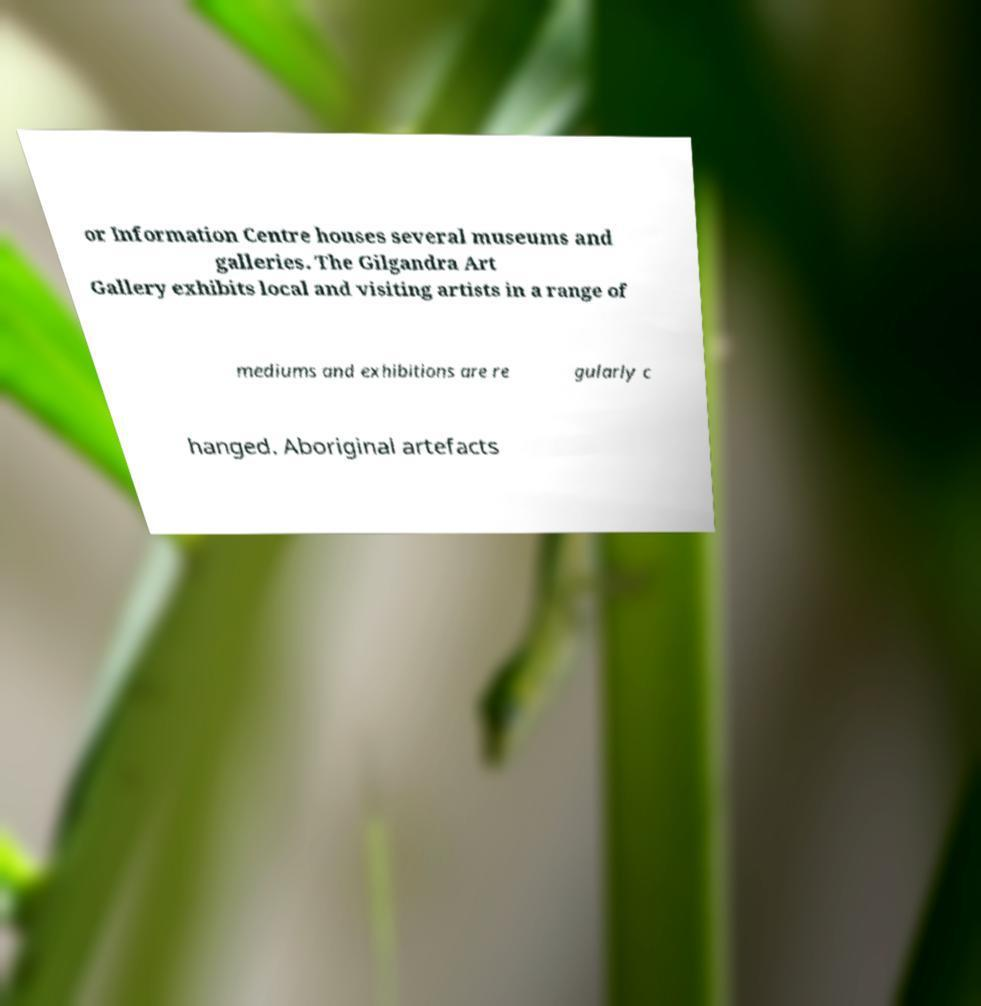What messages or text are displayed in this image? I need them in a readable, typed format. or Information Centre houses several museums and galleries. The Gilgandra Art Gallery exhibits local and visiting artists in a range of mediums and exhibitions are re gularly c hanged. Aboriginal artefacts 